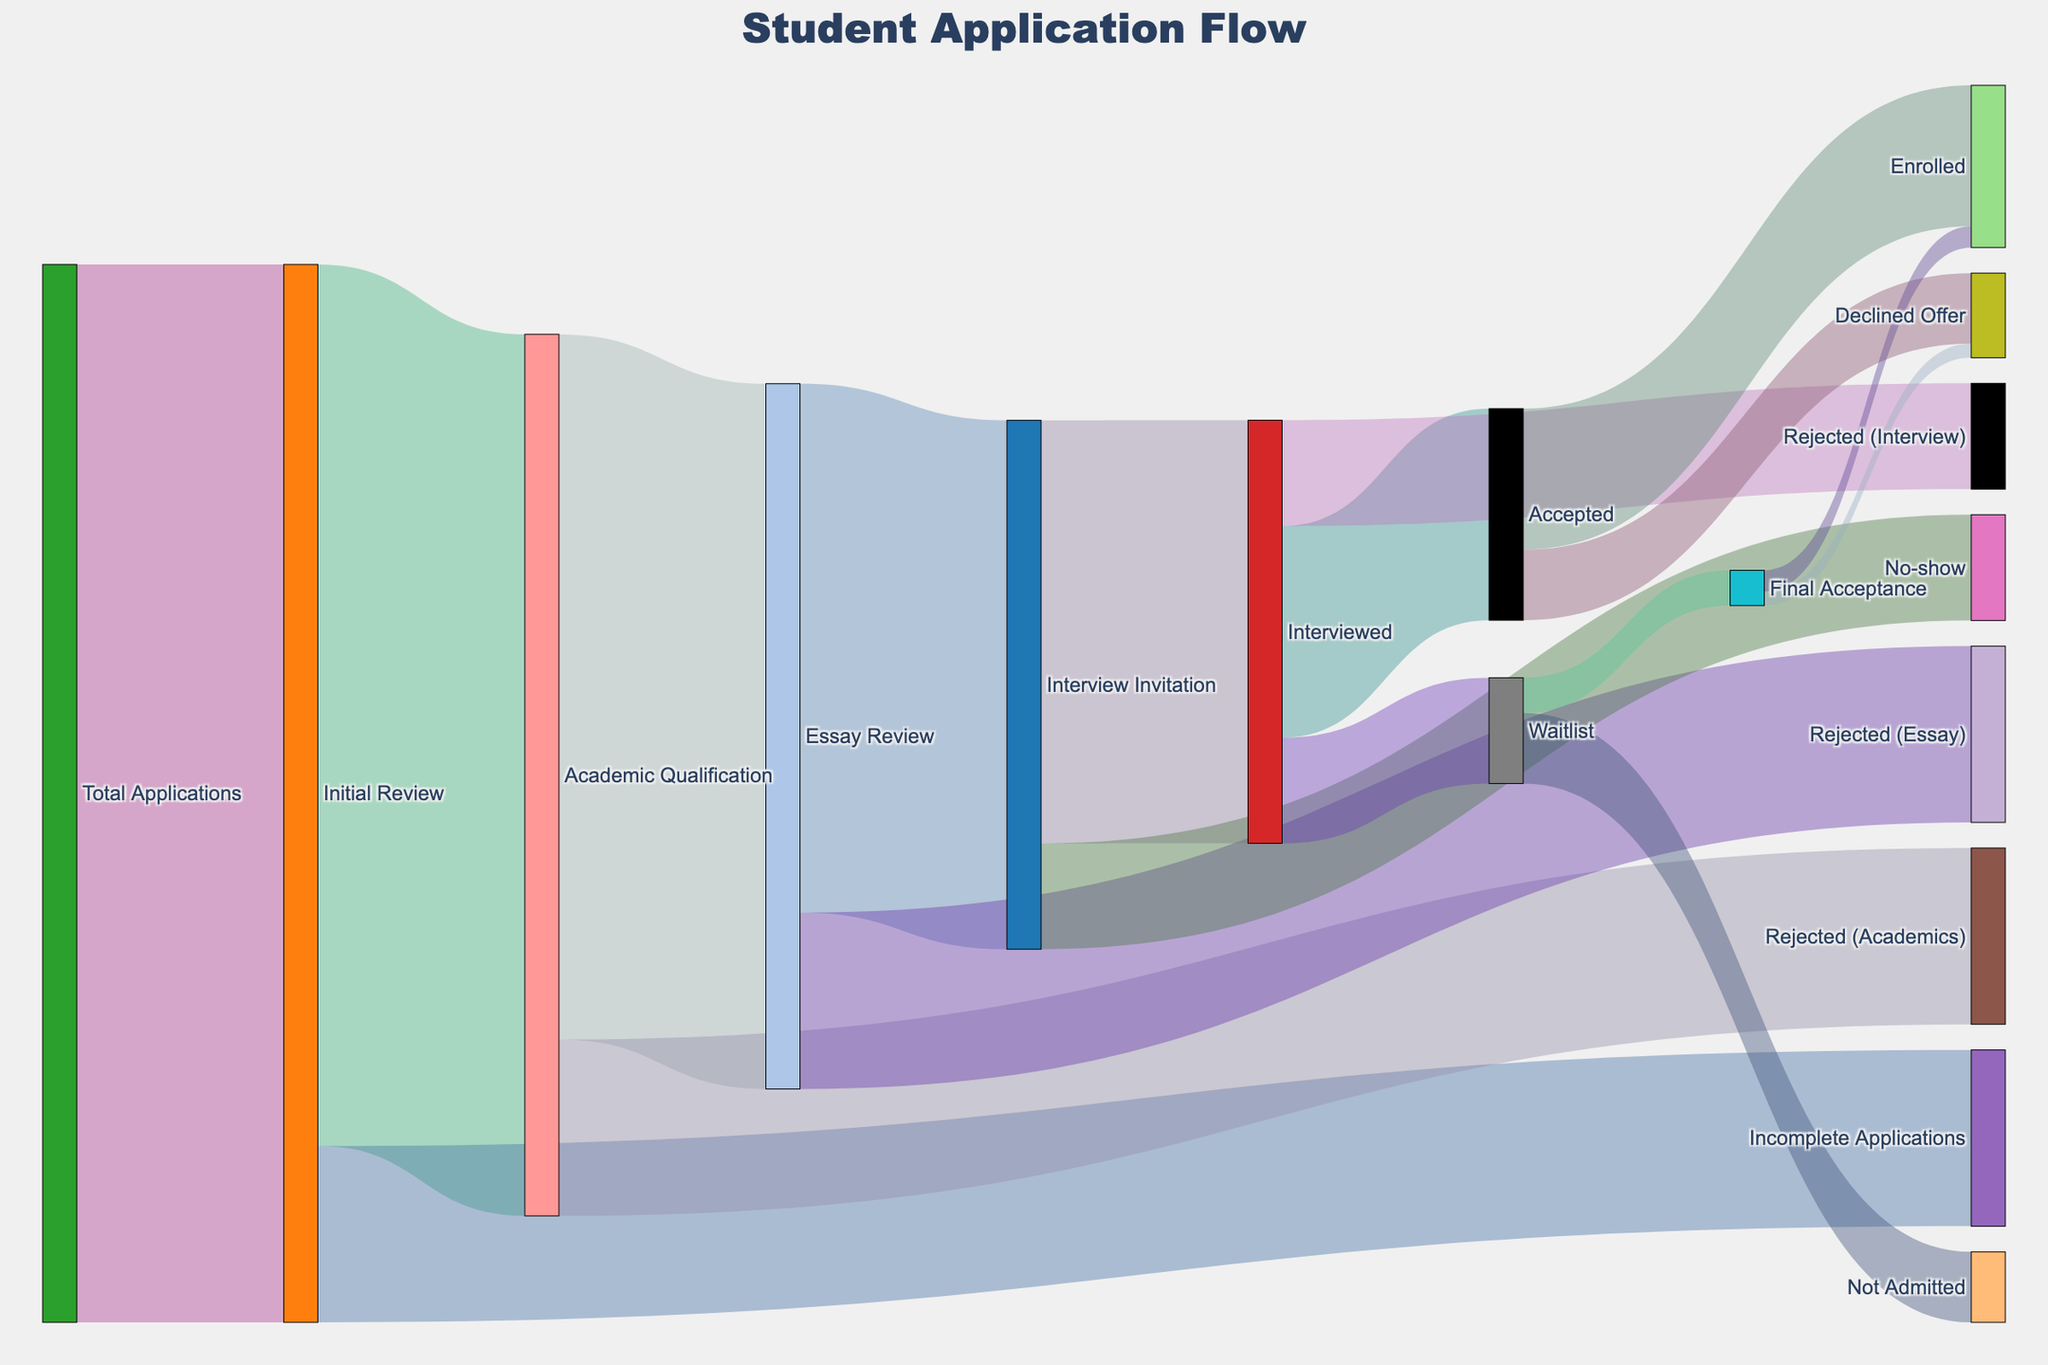How many total applications were received? The "Total Applications" node indicates the starting point with a value labeled "15000."
Answer: 15000 How many applications were academically qualified after the initial review? Starting with "Initial Review" (15000), 12500 were academically qualified as they flow to "Academic Qualification."
Answer: 12500 How many applications were incomplete after the initial review? From "Initial Review" (15000), 2500 were identified as "Incomplete Applications."
Answer: 2500 What was the outcome of the academically qualified applications at the essay review stage? Out of 12500 academically qualified applications, 10000 went to "Essay Review" and 2500 were "Rejected (Academics)."
Answer: 10000 went to "Essay Review" and 2500 were "Rejected (Academics)." How many interviewed candidates were waitlisted? "Interviewed" has 6000 candidates, out of which 1500 were shifted to the "Waitlist."
Answer: 1500 What is the total number of final enrollments from all stages? Enrollments are from "Accepted" (2000) and "Final Acceptance" (300), totaling 2300.
Answer: 2300 How many applicants accepted their offer after being final accepted? "Final Acceptance" node shows that 500 were "Waitlist," out of which 300 "Enrolled" and 200 "Declined Offer." Therefore, 300 from final acceptance enrolled.
Answer: 300 Compare the number of students rejected after essay review and interviews. 2500 were rejected at the "Essay Review" stage and 1500 were rejected after the "Interview" stage.
Answer: 2500 were rejected at "Essay Review" and 1500 at "Interview." How many academically qualified students were eventually accepted after all stages? Following from "Academic Qualification" (12500): "Essay Review" (10000), "Interview" (7500), and "Accepted" or "Final Acceptance" (3000+500) = 3500.
Answer: 3500 What proportion of interviewed candidates enrolled versus declined the offer? From the "Interview" stage, 3000 were "Accepted," and out of those, 2000 "Enrolled" and 1000 "Declined Offer." The proportion is 2000 enrolled to 1000 declined, making it 2:1.
Answer: 2:1 